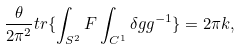Convert formula to latex. <formula><loc_0><loc_0><loc_500><loc_500>\frac { \theta } { 2 \pi ^ { 2 } } t r \{ \int _ { S ^ { 2 } } F \int _ { C ^ { 1 } } \delta g g ^ { - 1 } \} = 2 \pi k ,</formula> 